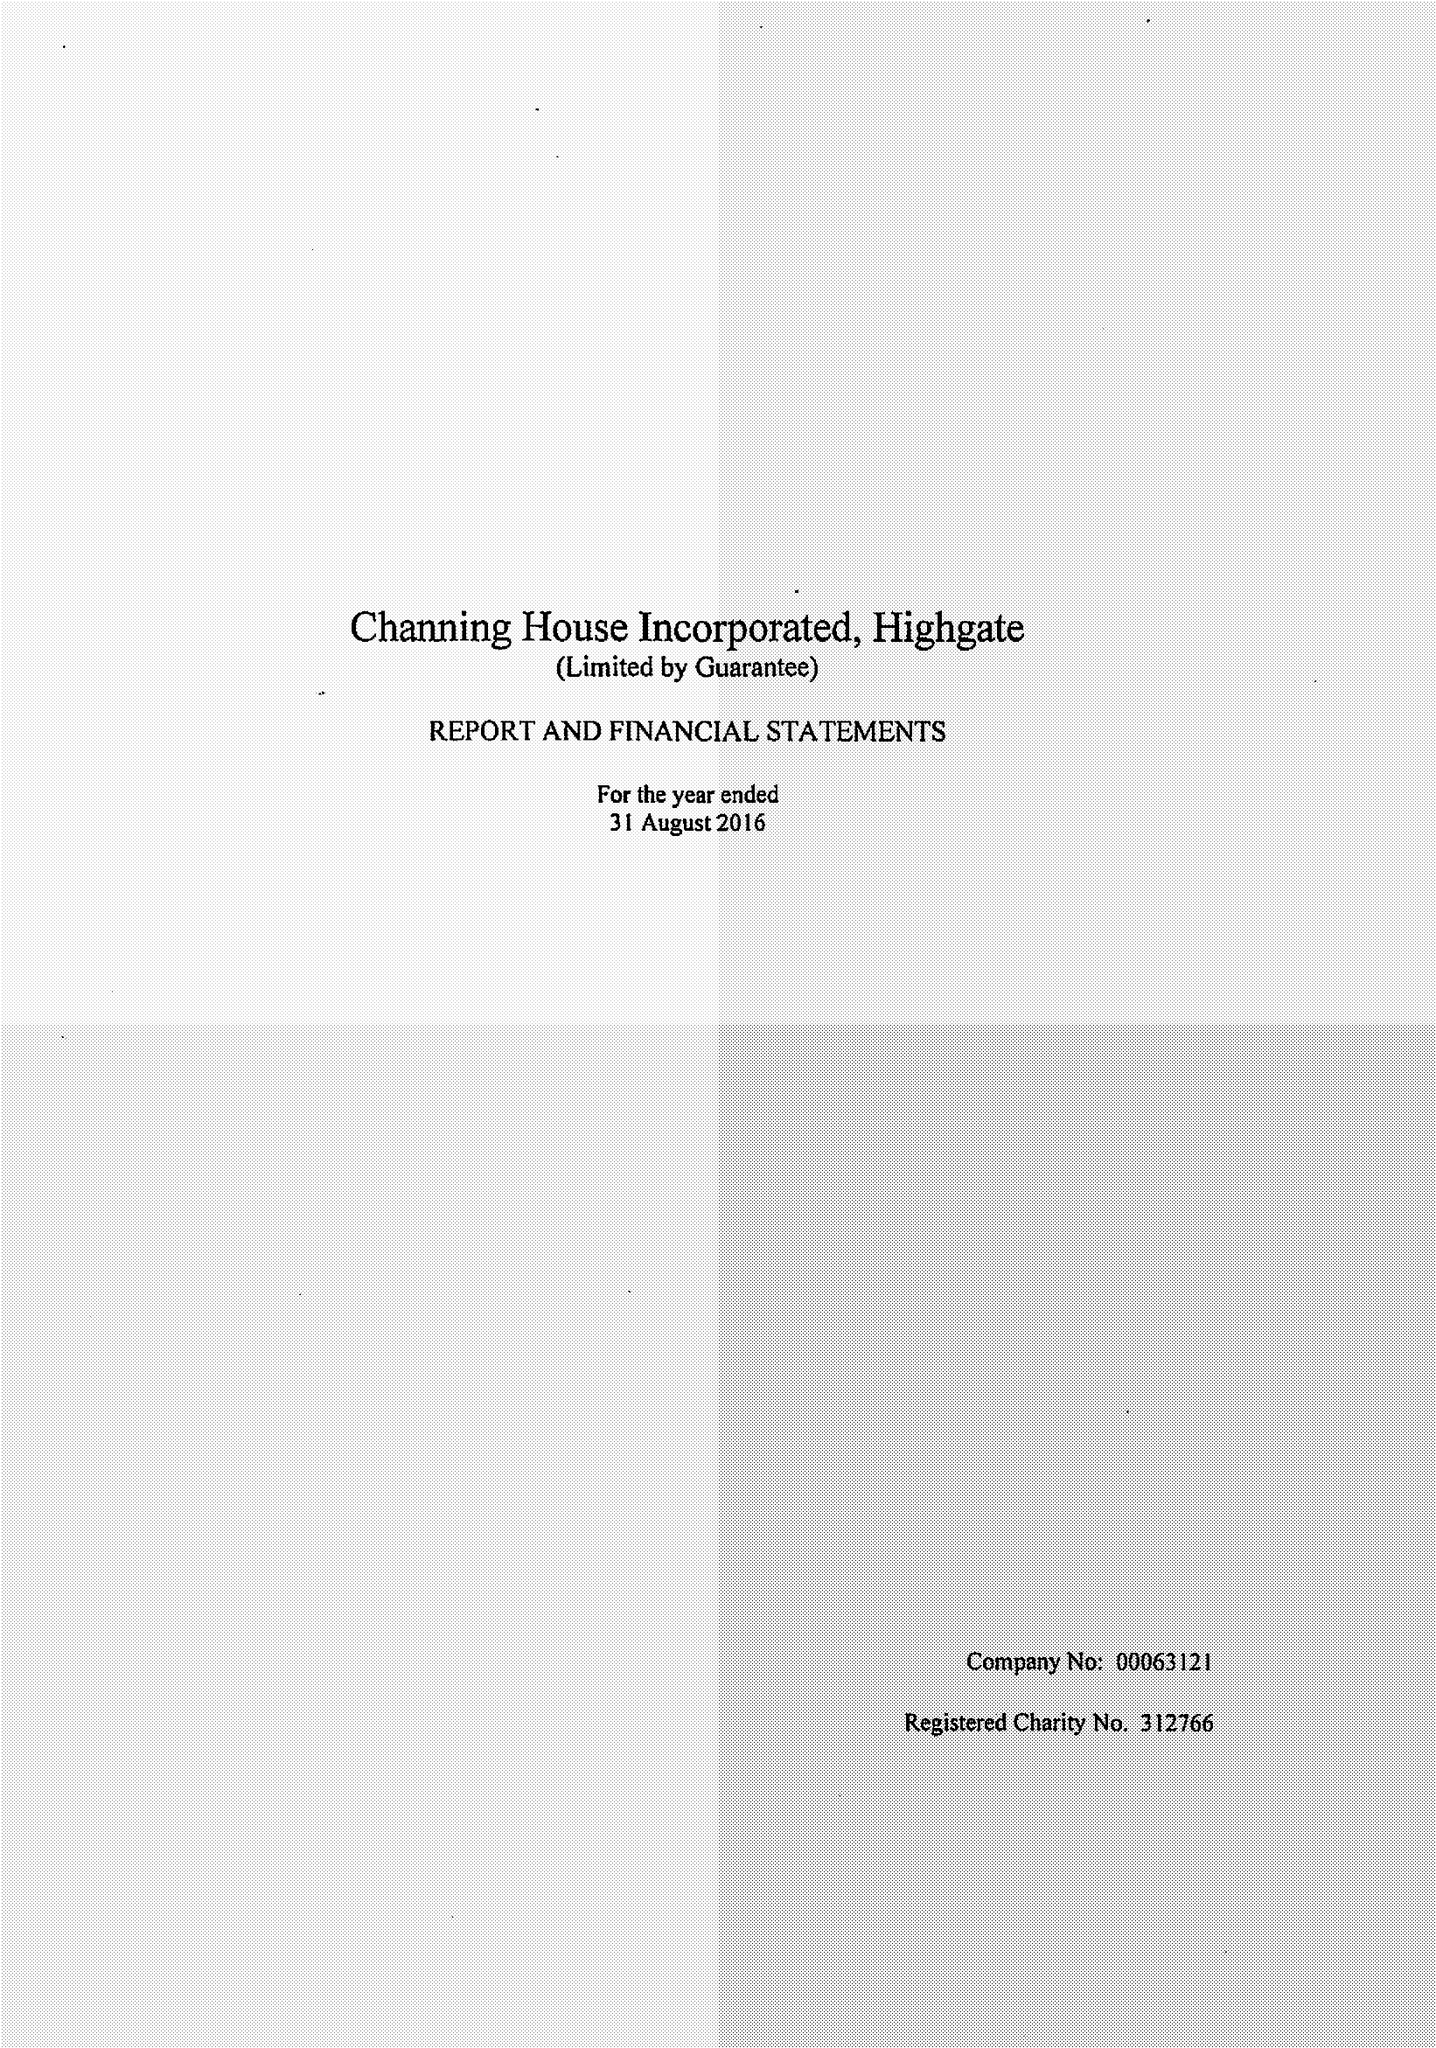What is the value for the address__postcode?
Answer the question using a single word or phrase. N6 5HF 